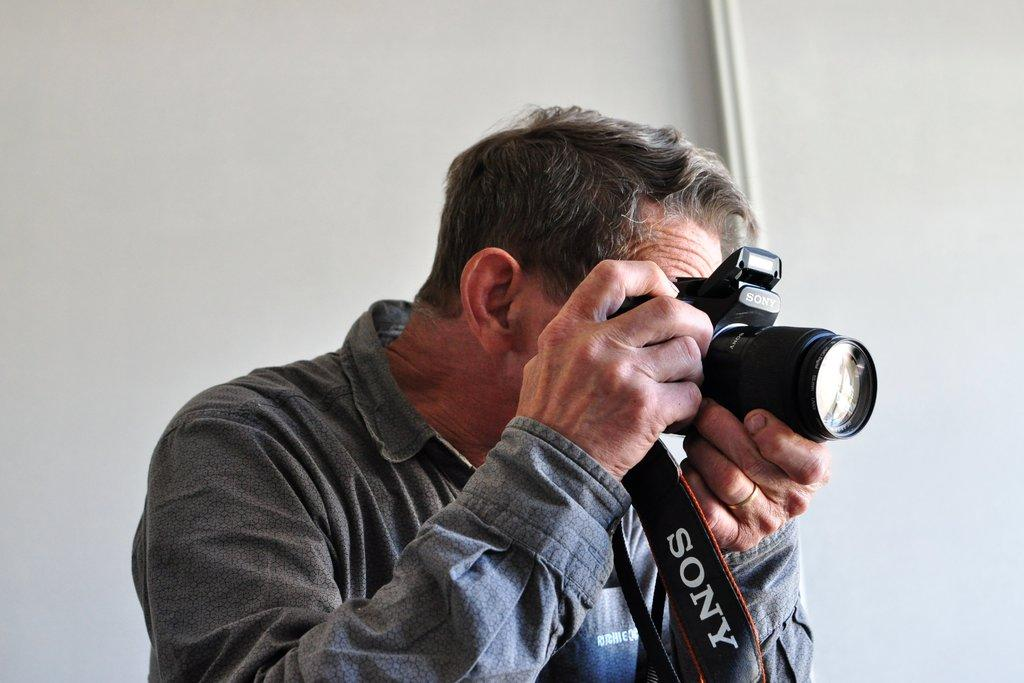Who is the main subject in the image? There is a man in the image. What is the man holding in his hand? The man is holding a camera in his hand. What is the man doing with the camera? The man is taking a picture. What type of dinosaurs can be seen in the background of the image? There are no dinosaurs present in the image. 